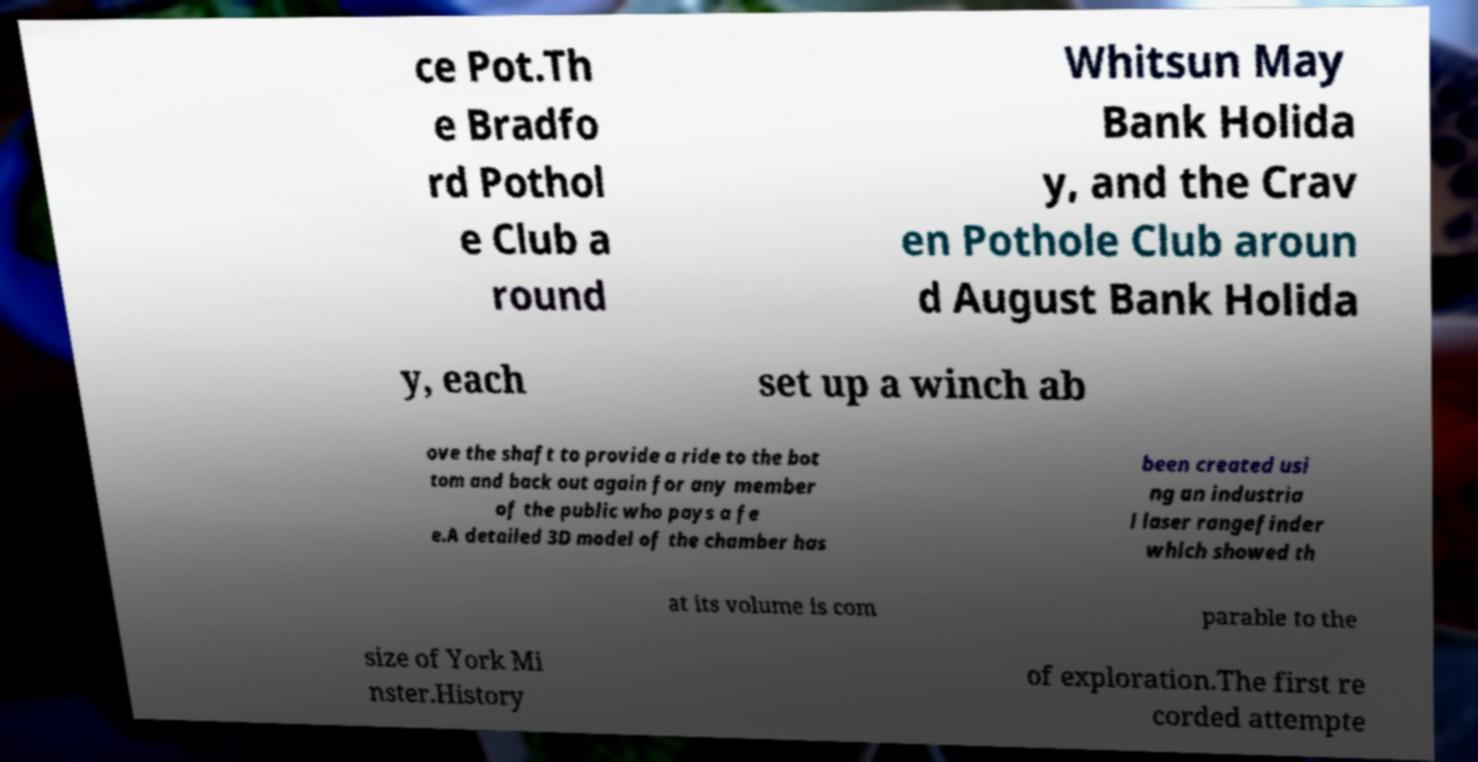There's text embedded in this image that I need extracted. Can you transcribe it verbatim? ce Pot.Th e Bradfo rd Pothol e Club a round Whitsun May Bank Holida y, and the Crav en Pothole Club aroun d August Bank Holida y, each set up a winch ab ove the shaft to provide a ride to the bot tom and back out again for any member of the public who pays a fe e.A detailed 3D model of the chamber has been created usi ng an industria l laser rangefinder which showed th at its volume is com parable to the size of York Mi nster.History of exploration.The first re corded attempte 